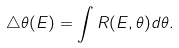Convert formula to latex. <formula><loc_0><loc_0><loc_500><loc_500>\bigtriangleup \theta ( E ) = \int R ( E , \theta ) d \theta .</formula> 